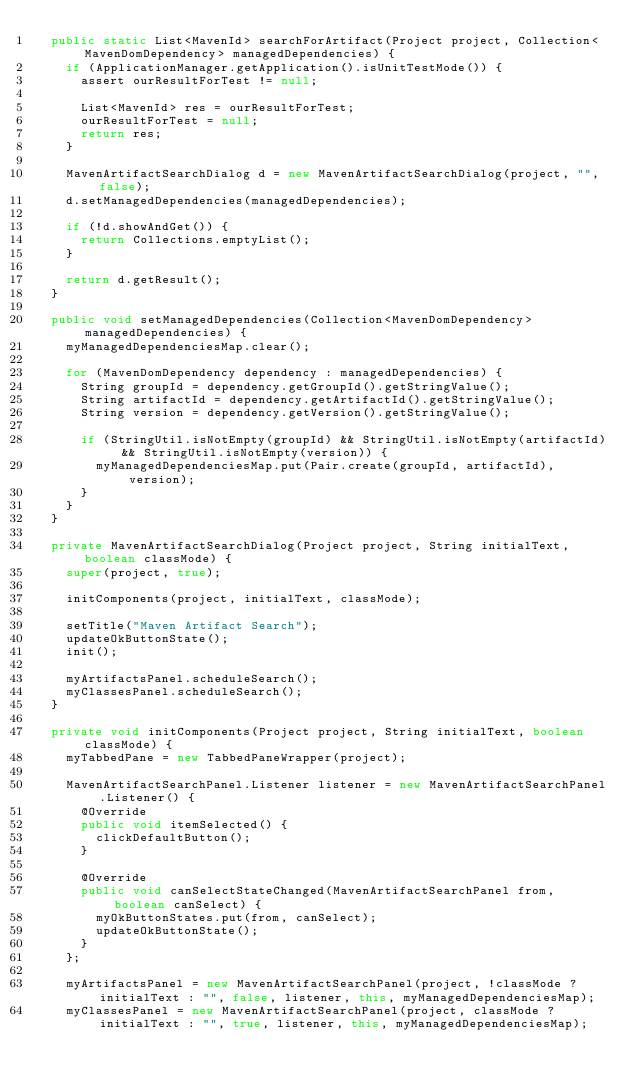<code> <loc_0><loc_0><loc_500><loc_500><_Java_>  public static List<MavenId> searchForArtifact(Project project, Collection<MavenDomDependency> managedDependencies) {
    if (ApplicationManager.getApplication().isUnitTestMode()) {
      assert ourResultForTest != null;

      List<MavenId> res = ourResultForTest;
      ourResultForTest = null;
      return res;
    }

    MavenArtifactSearchDialog d = new MavenArtifactSearchDialog(project, "", false);
    d.setManagedDependencies(managedDependencies);

    if (!d.showAndGet()) {
      return Collections.emptyList();
    }

    return d.getResult();
  }

  public void setManagedDependencies(Collection<MavenDomDependency> managedDependencies) {
    myManagedDependenciesMap.clear();

    for (MavenDomDependency dependency : managedDependencies) {
      String groupId = dependency.getGroupId().getStringValue();
      String artifactId = dependency.getArtifactId().getStringValue();
      String version = dependency.getVersion().getStringValue();

      if (StringUtil.isNotEmpty(groupId) && StringUtil.isNotEmpty(artifactId) && StringUtil.isNotEmpty(version)) {
        myManagedDependenciesMap.put(Pair.create(groupId, artifactId), version);
      }
    }
  }

  private MavenArtifactSearchDialog(Project project, String initialText, boolean classMode) {
    super(project, true);

    initComponents(project, initialText, classMode);

    setTitle("Maven Artifact Search");
    updateOkButtonState();
    init();

    myArtifactsPanel.scheduleSearch();
    myClassesPanel.scheduleSearch();
  }

  private void initComponents(Project project, String initialText, boolean classMode) {
    myTabbedPane = new TabbedPaneWrapper(project);

    MavenArtifactSearchPanel.Listener listener = new MavenArtifactSearchPanel.Listener() {
      @Override
      public void itemSelected() {
        clickDefaultButton();
      }

      @Override
      public void canSelectStateChanged(MavenArtifactSearchPanel from, boolean canSelect) {
        myOkButtonStates.put(from, canSelect);
        updateOkButtonState();
      }
    };

    myArtifactsPanel = new MavenArtifactSearchPanel(project, !classMode ? initialText : "", false, listener, this, myManagedDependenciesMap);
    myClassesPanel = new MavenArtifactSearchPanel(project, classMode ? initialText : "", true, listener, this, myManagedDependenciesMap);
</code> 